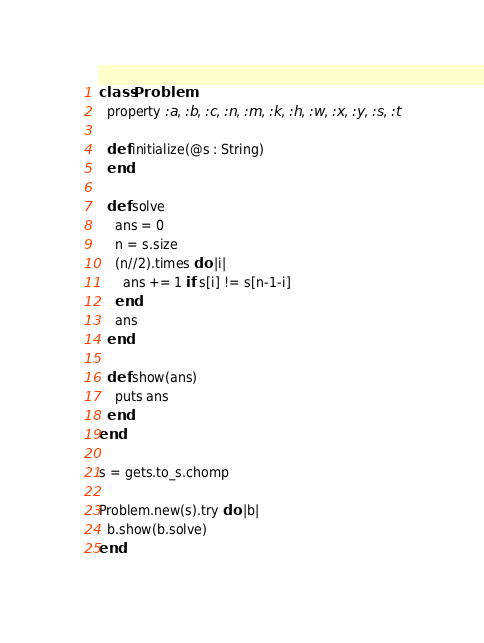Convert code to text. <code><loc_0><loc_0><loc_500><loc_500><_Crystal_>class Problem
  property :a, :b, :c, :n, :m, :k, :h, :w, :x, :y, :s, :t

  def initialize(@s : String)
  end

  def solve
    ans = 0
    n = s.size
    (n//2).times do |i|
      ans += 1 if s[i] != s[n-1-i]
    end
    ans
  end

  def show(ans)
    puts ans
  end
end

s = gets.to_s.chomp

Problem.new(s).try do |b|
  b.show(b.solve)
end
</code> 